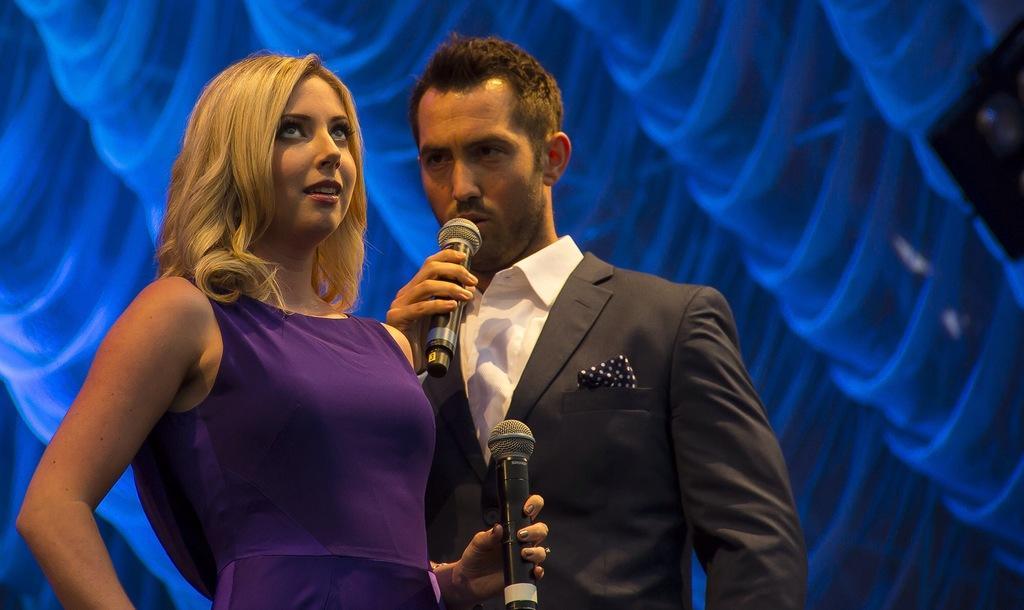In one or two sentences, can you explain what this image depicts? Here we can see a woman and a man holding a mike with their hands. He is in black suit. 